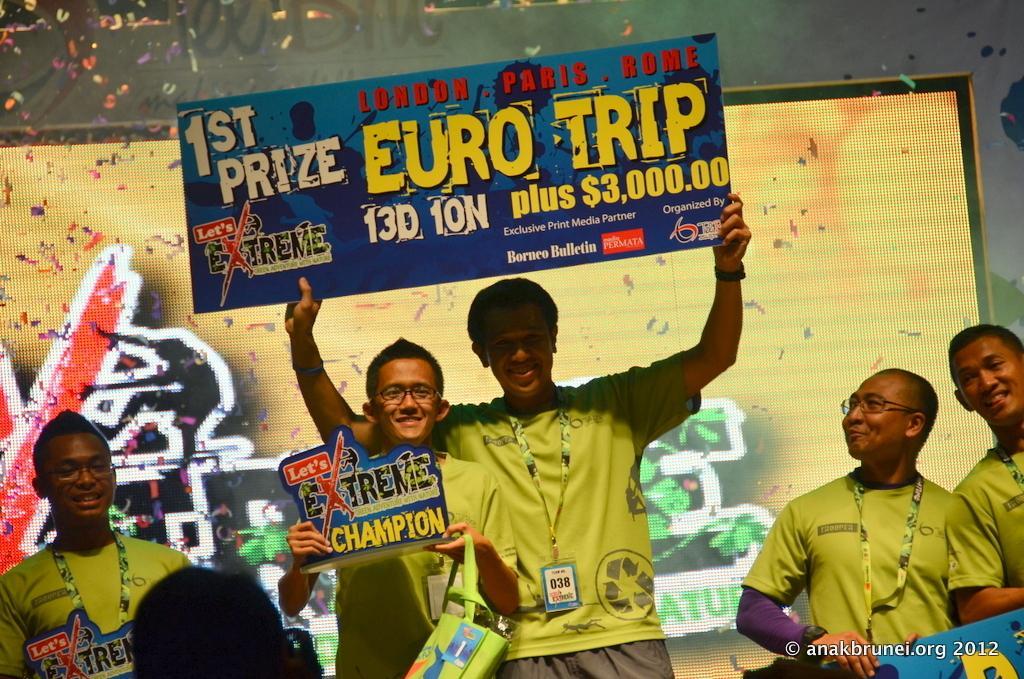Can you describe this image briefly? In the image there are few men standing and there are wearing green t-shirts. Those people are holding trophies in their hands. Behind them there is a screen. 